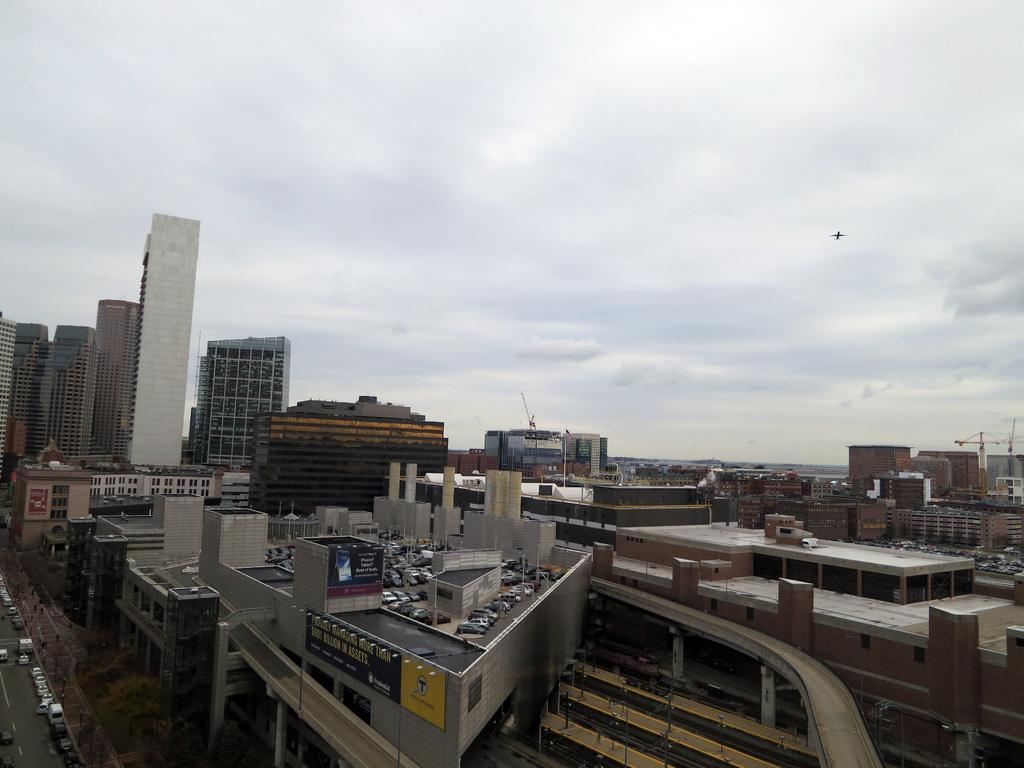Please provide a concise description of this image. This is an outside view. Here I can see many buildings. In the bottom left, I can see few cars on the road. At the top of the image I can see the sky. 